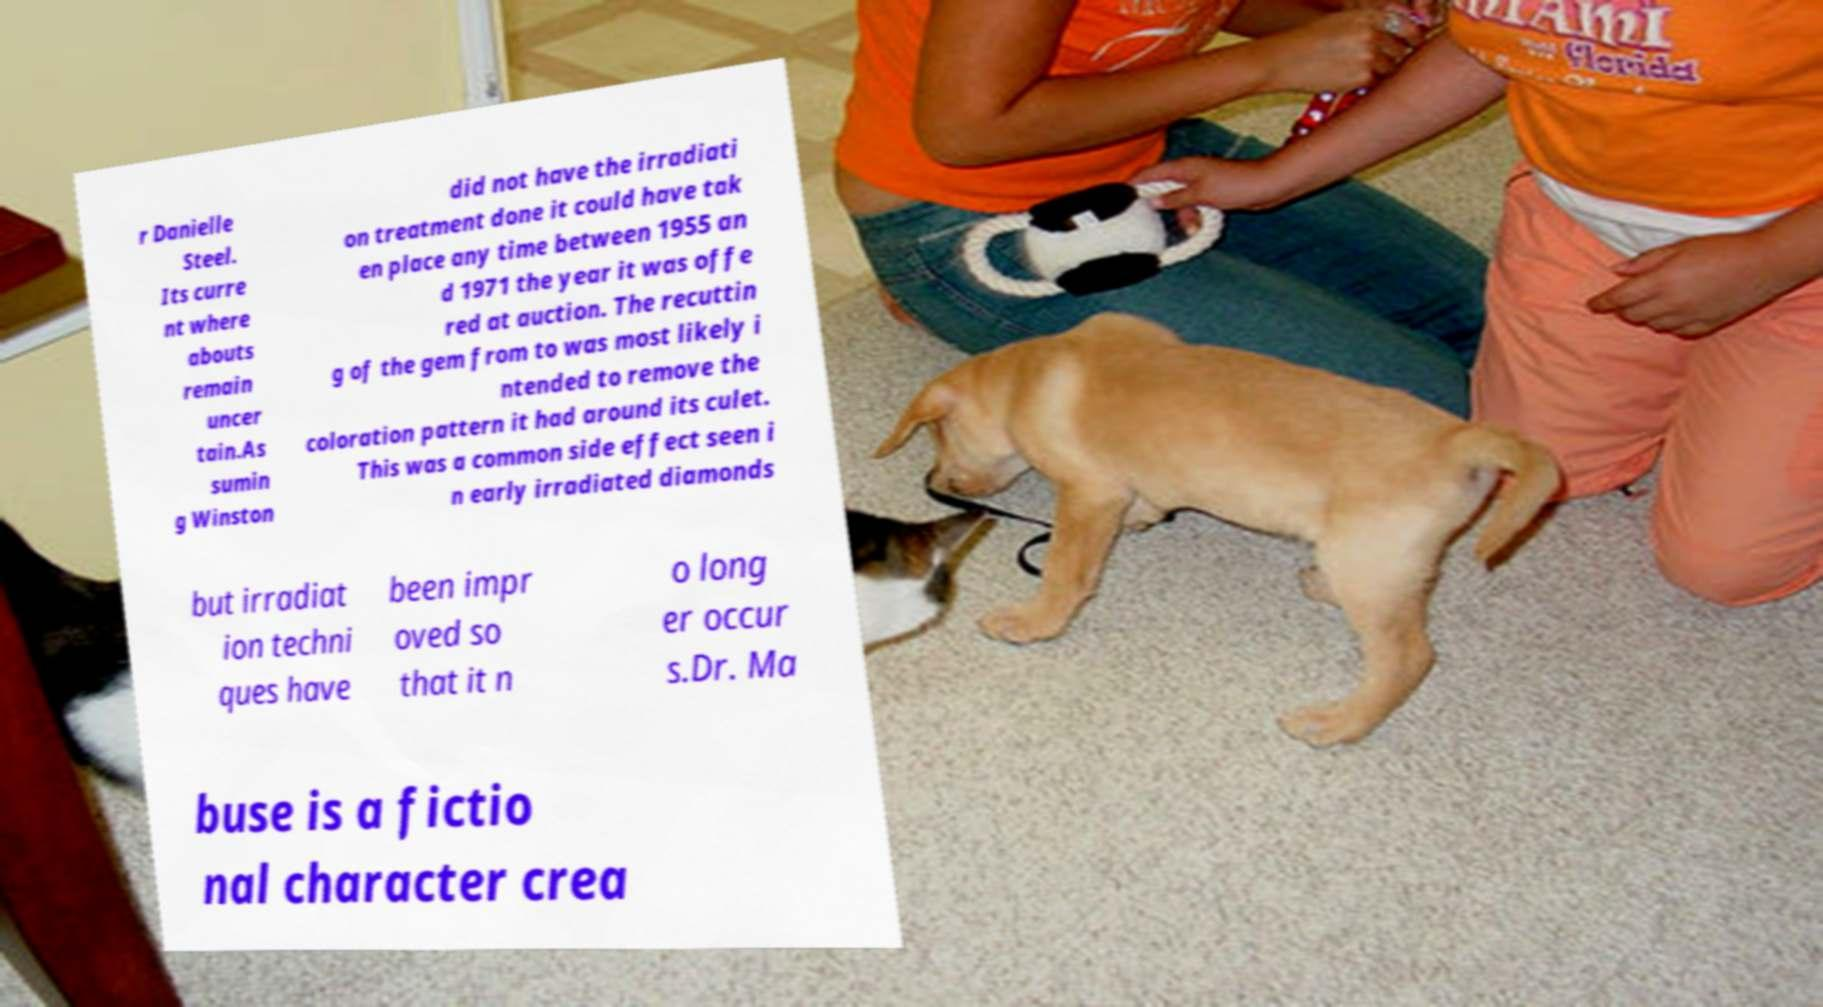What messages or text are displayed in this image? I need them in a readable, typed format. r Danielle Steel. Its curre nt where abouts remain uncer tain.As sumin g Winston did not have the irradiati on treatment done it could have tak en place any time between 1955 an d 1971 the year it was offe red at auction. The recuttin g of the gem from to was most likely i ntended to remove the coloration pattern it had around its culet. This was a common side effect seen i n early irradiated diamonds but irradiat ion techni ques have been impr oved so that it n o long er occur s.Dr. Ma buse is a fictio nal character crea 